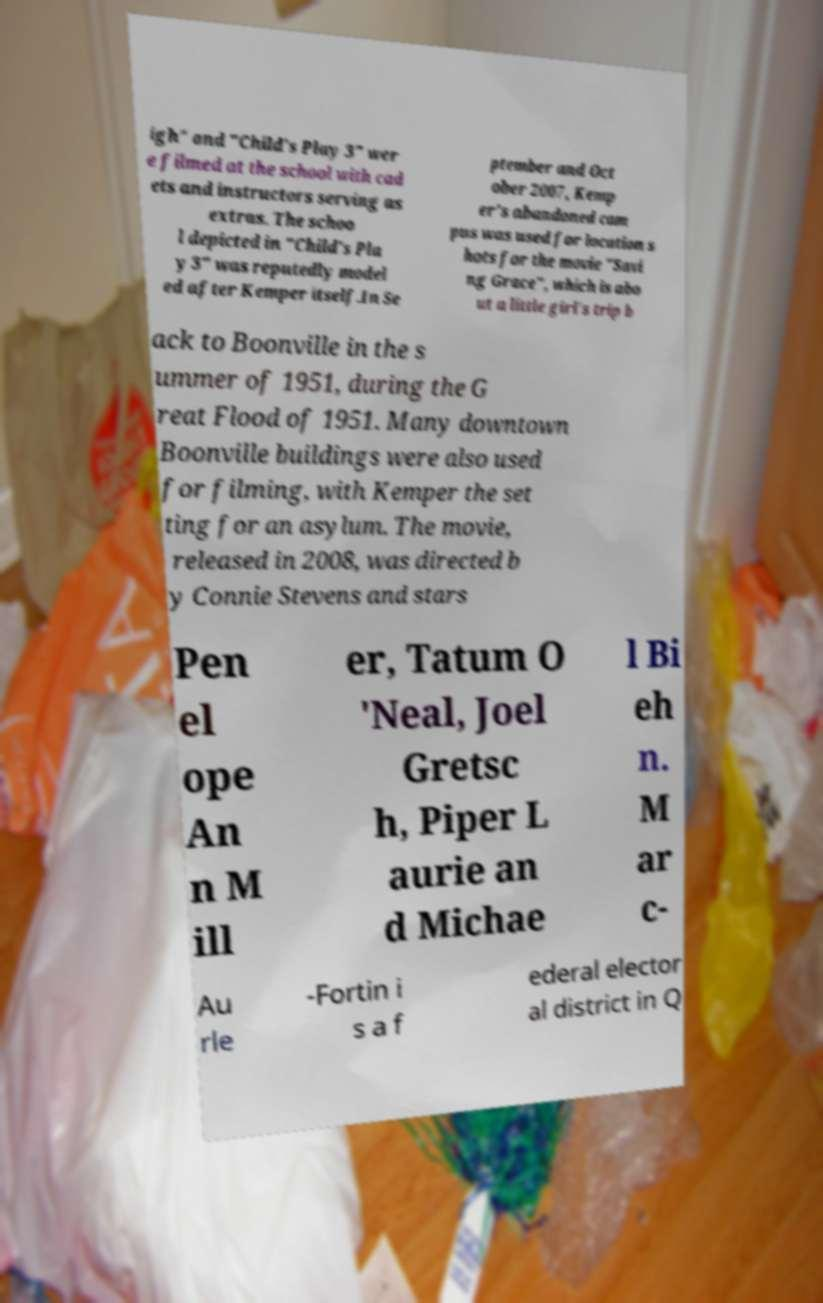Could you assist in decoding the text presented in this image and type it out clearly? igh" and "Child's Play 3" wer e filmed at the school with cad ets and instructors serving as extras. The schoo l depicted in "Child's Pla y 3" was reputedly model ed after Kemper itself.In Se ptember and Oct ober 2007, Kemp er's abandoned cam pus was used for location s hots for the movie "Savi ng Grace", which is abo ut a little girl's trip b ack to Boonville in the s ummer of 1951, during the G reat Flood of 1951. Many downtown Boonville buildings were also used for filming, with Kemper the set ting for an asylum. The movie, released in 2008, was directed b y Connie Stevens and stars Pen el ope An n M ill er, Tatum O 'Neal, Joel Gretsc h, Piper L aurie an d Michae l Bi eh n. M ar c- Au rle -Fortin i s a f ederal elector al district in Q 